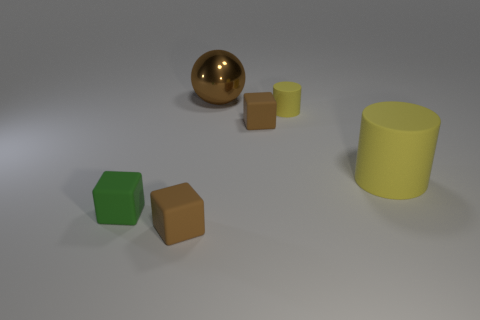Is there a big object of the same color as the tiny cylinder? Yes, there is a larger cylinder farthest to the right that shares the same light yellow color as the tiny cylinder. 